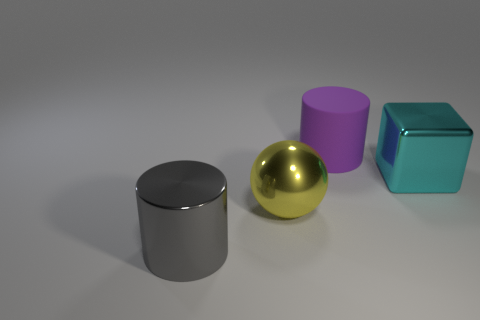Is there anything else that is made of the same material as the purple object?
Offer a terse response. No. What is the color of the cylinder that is behind the big object in front of the yellow thing?
Ensure brevity in your answer.  Purple. Are there fewer large gray cylinders than large cylinders?
Keep it short and to the point. Yes. Are there any large cyan objects made of the same material as the yellow thing?
Provide a succinct answer. Yes. Is the shape of the large gray shiny thing the same as the thing behind the metallic cube?
Give a very brief answer. Yes. There is a gray cylinder; are there any cylinders to the right of it?
Offer a very short reply. Yes. How many other big things are the same shape as the yellow metallic object?
Make the answer very short. 0. Does the cube have the same material as the cylinder on the left side of the yellow metallic sphere?
Offer a very short reply. Yes. How many large gray things are there?
Your response must be concise. 1. How many gray metal objects are the same size as the shiny cylinder?
Keep it short and to the point. 0. 